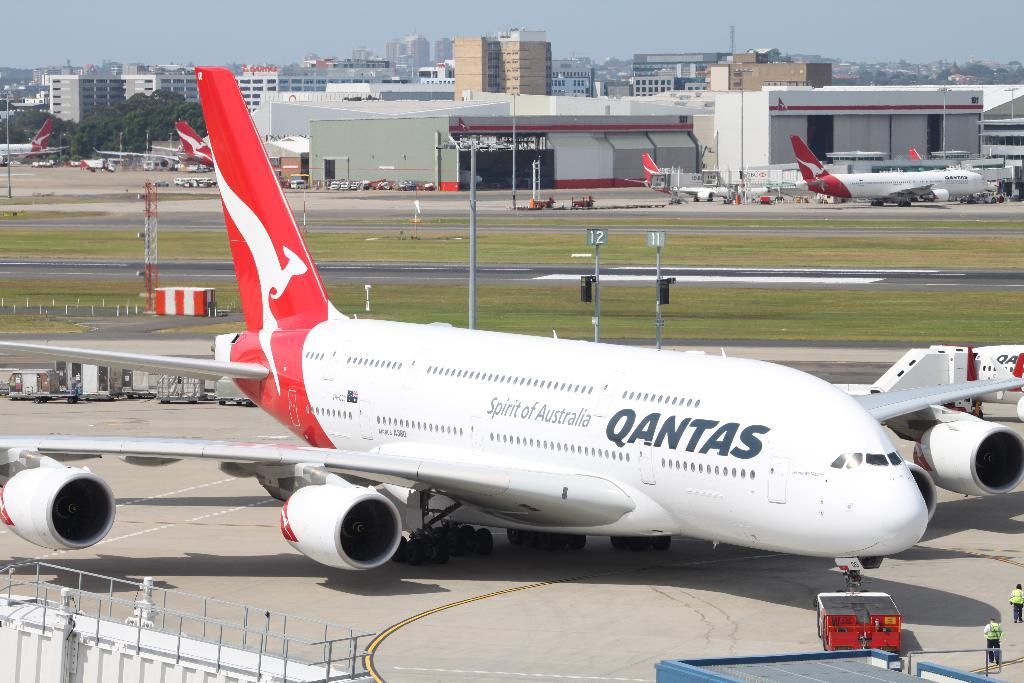Provide a one-sentence caption for the provided image. a Qantas airlines plane sits on the tarmac waiting to be serviced. 